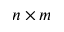<formula> <loc_0><loc_0><loc_500><loc_500>n \times m</formula> 